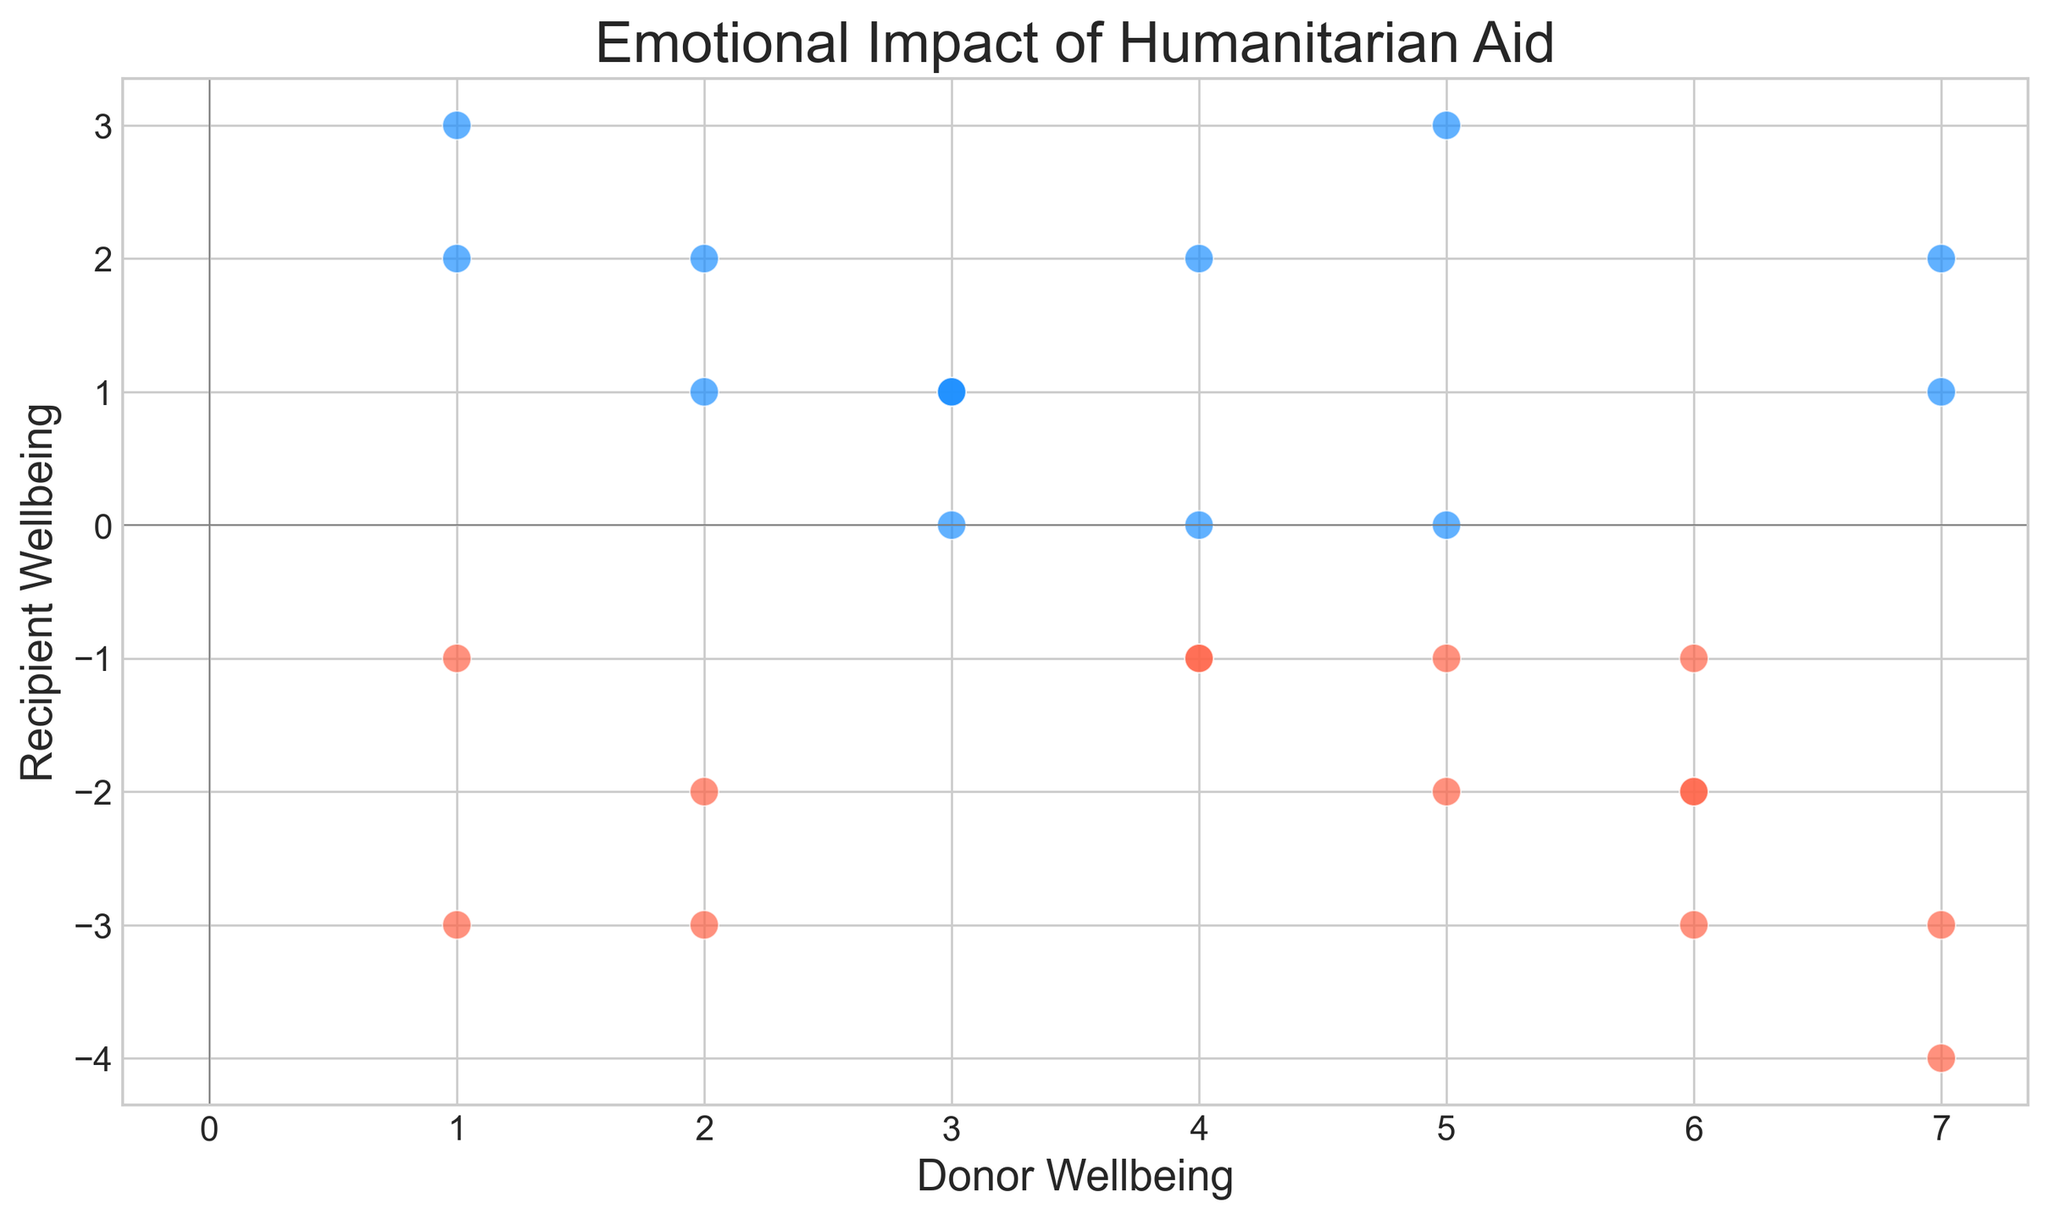What's the average well-being for donors? To find the average well-being for donors, sum all the data points for donor well-being and divide by the total number of data points. The sum of the donor well-being values is 86. There are 28 data points. Thus, the average donor well-being is 86/28.
Answer: 3.07 Are there more positive or negative well-being values for recipients? Count the number of positive and negative values for recipient well-being. There are 12 positive and 16 negative values. Therefore, there are more negative values.
Answer: Negative What is the most common donor well-being value? Identify the donor well-being value that appears most frequently. The value 3 appears 5 times, which is more frequent than any other value.
Answer: 3 Which well-being value has the highest range for recipients? The range is calculated by subtracting the minimum value from the maximum value. For recipients, the maximum value is 3 and the minimum value is -4. The range thus is 3 - (-4) = 7.
Answer: 7 Is there a donor well-being value that corresponds to a recipient well-being of zero? Look at the data points where the recipient well-being is zero and check the corresponding donor well-being value. The recipient well-being of zero corresponds to donor well-being values of 5, 3, and 4.
Answer: Yes What's the total number of negative well-being values for donors? Count how many of the donor well-being values are less than zero. There are no negative values for donor well-being in the dataset.
Answer: 0 What is the correlation between donor and recipient well-being for paired data points? Evaluate whether there is a visible pattern or trend in the scatter plot. A negative slope in the scatter plot suggests a negative correlation. Most points show that as donor well-being increases, recipient well-being becomes more negative.
Answer: Negative Which donor well-being value corresponds to the highest recipient well-being value? Identify the data point with the highest recipient well-being value and check the corresponding donor well-being value. A recipient well-being of 3 corresponds to a donor well-being of 1 and 5.
Answer: 1 and 5 What percentage of recipients have a well-being value below zero? Count the total number of recipient well-being values and the number of those values below zero, then divide the number below zero by the total and multiply by 100. There are 16 negative out of 28 values. Thus, (16/28) * 100 = 57.14%.
Answer: 57.14% Which color represents positive recipient well-being values in the scatter plot? The scatter plot uses two colors for recipient well-being: one for positive and one for negative values. The plot description mentions using 'dodgerblue' for positive values. 'Dodgerblue' corresponds to blue.
Answer: Blue 